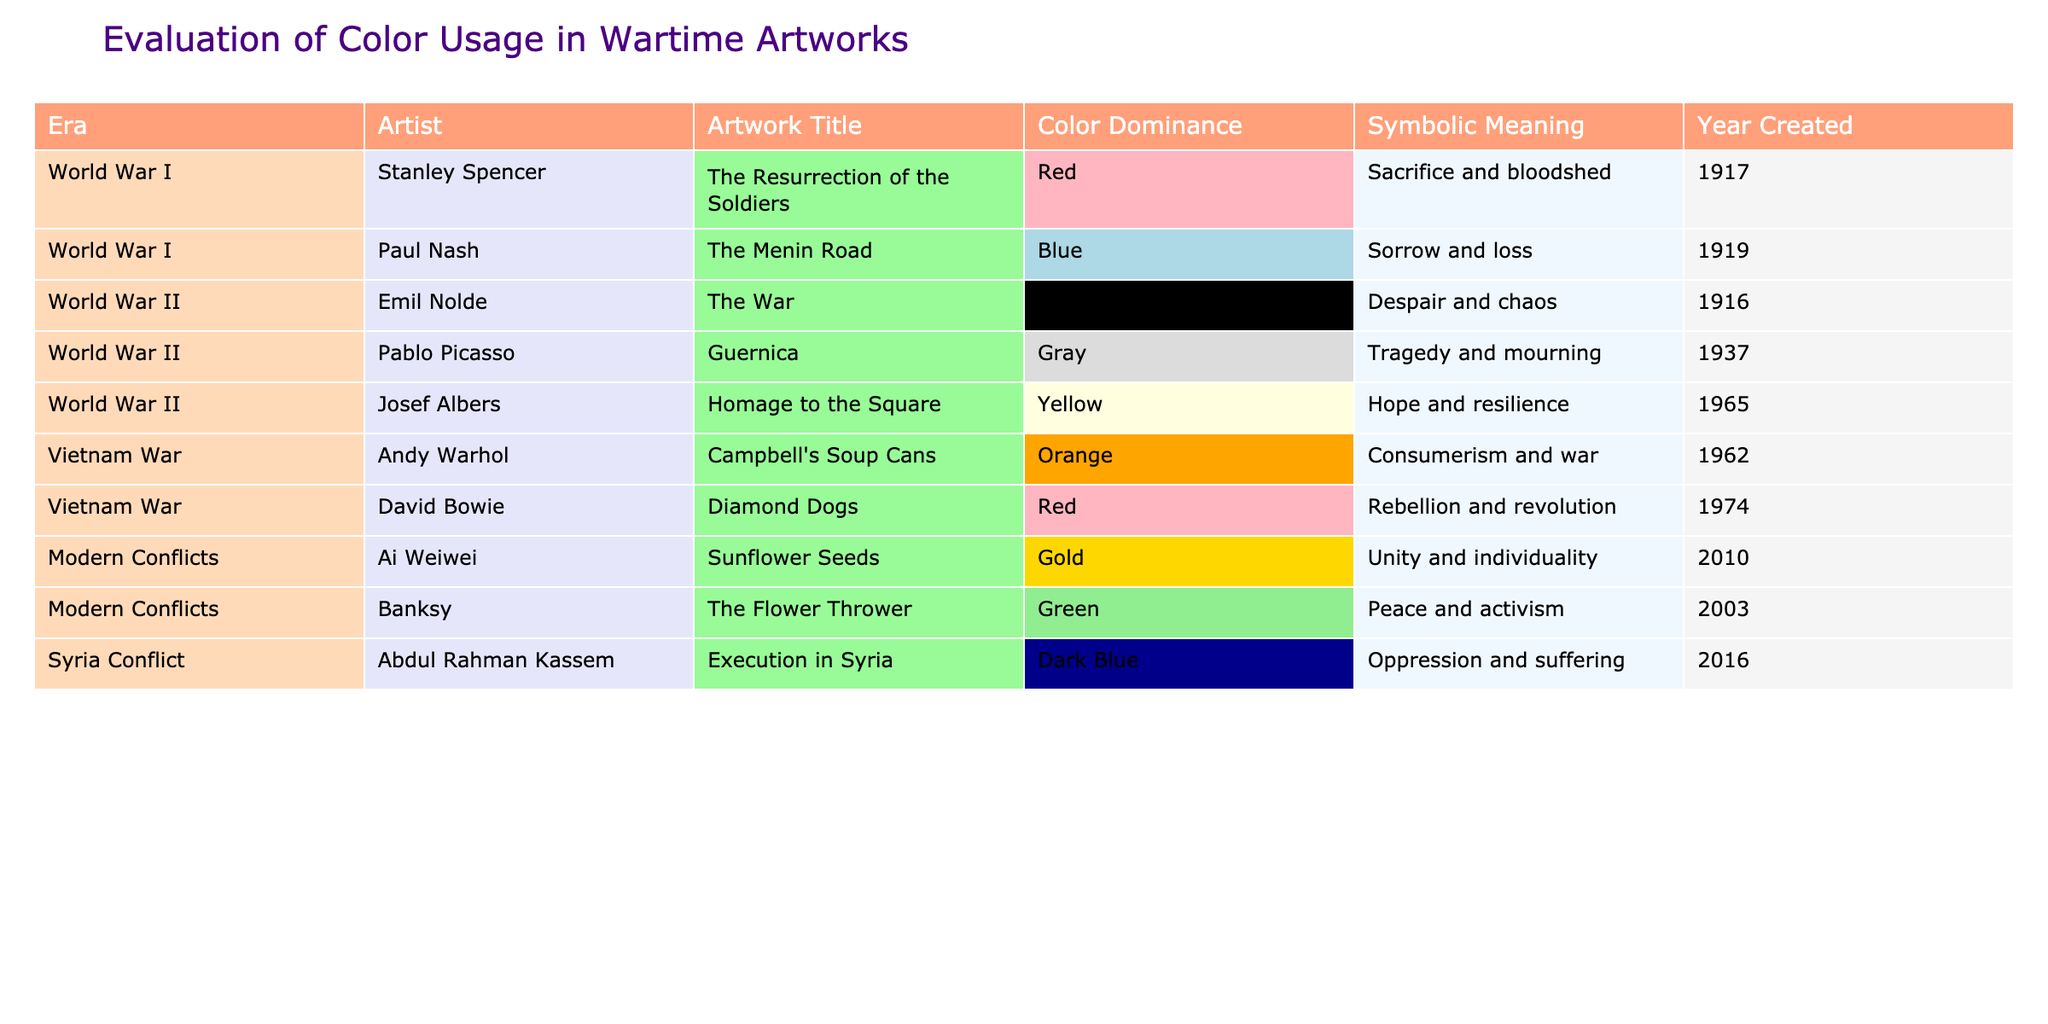What color is most commonly associated with sacrifice in World War I artworks? According to the table, the artwork "The Resurrection of the Soldiers" by Stanley Spencer represents the color Red, which symbolizes sacrifice and bloodshed.
Answer: Red Which artist created an artwork associated with hope during World War II? Josef Albers created "Homage to the Square," which uses Yellow to symbolize hope and resilience in the context of World War II.
Answer: Josef Albers How many artworks from the Vietnam War era are represented in the table? The table lists two artworks from the Vietnam War era: "Campbell's Soup Cans" by Andy Warhol and "Diamond Dogs" by David Bowie.
Answer: 2 Which symbolic meaning is associated with the color Green in modern conflicts? The color Green, as represented by Banksy's artwork "The Flower Thrower," symbolizes peace and activism, indicating a desire for positive change in modern conflicts.
Answer: Peace and activism Is it true that there are artworks from the Syria conflict that use dark colors? Yes, "Execution in Syria" by Abdul Rahman Kassem uses Dark Blue, which symbolizes oppression and suffering, confirming the presence of dark colors in artworks about the Syria conflict.
Answer: Yes What is the average year of creation for the artworks associated with the Vietnam War? The years of the two artworks from the Vietnam War are 1962 (Warhol) and 1974 (Bowie). The average is (1962 + 1974) / 2 = 1968.
Answer: 1968 Which artwork has the darkest color and what does it symbolize? "The War" by Emil Nolde is the darkest artwork as it uses Black, symbolizing despair and chaos.
Answer: The War, despair and chaos Which era has the highest representation of artworks in the table? There are four artworks from World War II, which is more than any other era in the table.
Answer: World War II What symbolic meaning is depicted through the color Orange in wartime art? The color Orange in "Campbell's Soup Cans" by Andy Warhol symbolizes consumerism and war, reflecting the impact of war on culture and society.
Answer: Consumerism and war If the artworks using Red and Blue are combined, how many do they total? "The Resurrection of the Soldiers" (Red) and "The Menin Road" (Blue) combine for a total of 2 artworks that use these colors.
Answer: 2 